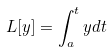<formula> <loc_0><loc_0><loc_500><loc_500>L [ y ] = \int _ { a } ^ { t } y d t</formula> 